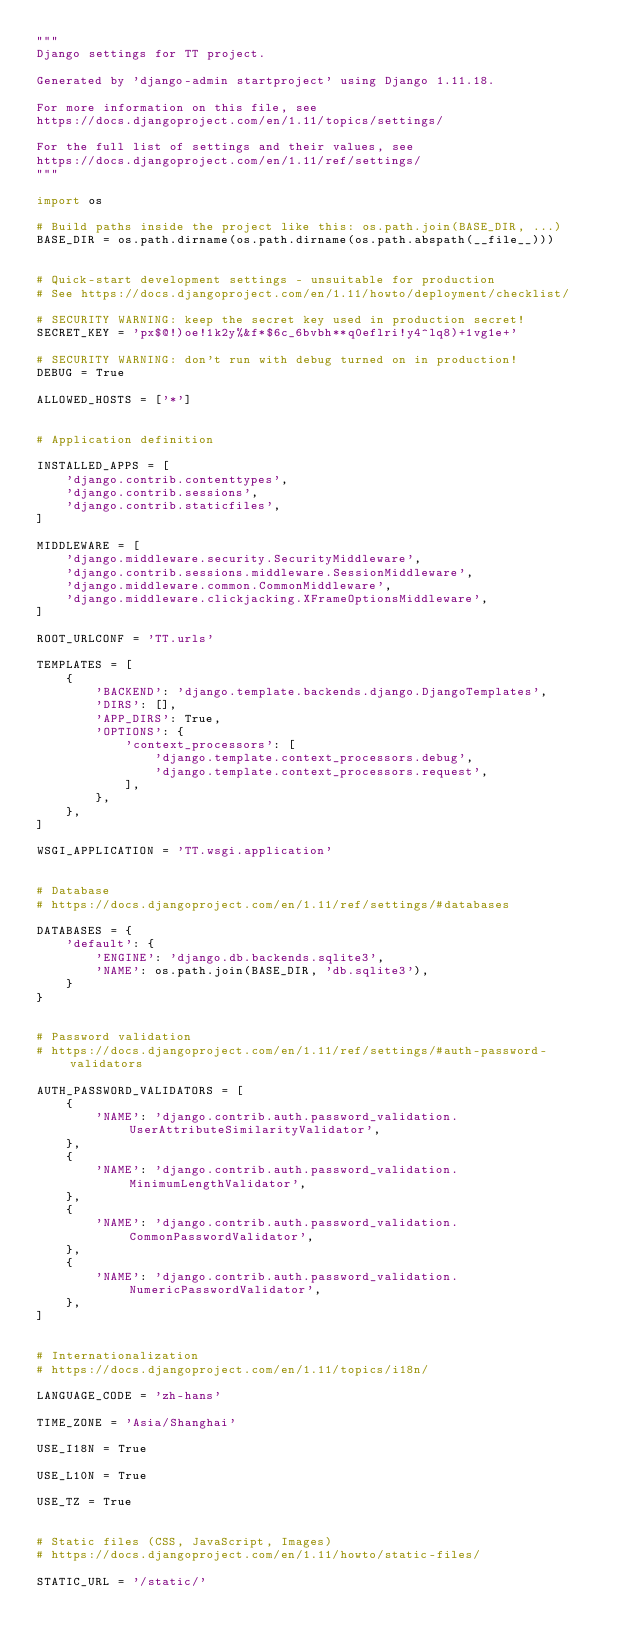<code> <loc_0><loc_0><loc_500><loc_500><_Python_>"""
Django settings for TT project.

Generated by 'django-admin startproject' using Django 1.11.18.

For more information on this file, see
https://docs.djangoproject.com/en/1.11/topics/settings/

For the full list of settings and their values, see
https://docs.djangoproject.com/en/1.11/ref/settings/
"""

import os

# Build paths inside the project like this: os.path.join(BASE_DIR, ...)
BASE_DIR = os.path.dirname(os.path.dirname(os.path.abspath(__file__)))


# Quick-start development settings - unsuitable for production
# See https://docs.djangoproject.com/en/1.11/howto/deployment/checklist/

# SECURITY WARNING: keep the secret key used in production secret!
SECRET_KEY = 'px$@!)oe!1k2y%&f*$6c_6bvbh**q0eflri!y4^lq8)+1vg1e+'

# SECURITY WARNING: don't run with debug turned on in production!
DEBUG = True

ALLOWED_HOSTS = ['*']


# Application definition

INSTALLED_APPS = [
    'django.contrib.contenttypes',
    'django.contrib.sessions',
    'django.contrib.staticfiles',
]

MIDDLEWARE = [
    'django.middleware.security.SecurityMiddleware',
    'django.contrib.sessions.middleware.SessionMiddleware',
    'django.middleware.common.CommonMiddleware',
    'django.middleware.clickjacking.XFrameOptionsMiddleware',
]

ROOT_URLCONF = 'TT.urls'

TEMPLATES = [
    {
        'BACKEND': 'django.template.backends.django.DjangoTemplates',
        'DIRS': [],
        'APP_DIRS': True,
        'OPTIONS': {
            'context_processors': [
                'django.template.context_processors.debug',
                'django.template.context_processors.request',
            ],
        },
    },
]

WSGI_APPLICATION = 'TT.wsgi.application'


# Database
# https://docs.djangoproject.com/en/1.11/ref/settings/#databases

DATABASES = {
    'default': {
        'ENGINE': 'django.db.backends.sqlite3',
        'NAME': os.path.join(BASE_DIR, 'db.sqlite3'),
    }
}


# Password validation
# https://docs.djangoproject.com/en/1.11/ref/settings/#auth-password-validators

AUTH_PASSWORD_VALIDATORS = [
    {
        'NAME': 'django.contrib.auth.password_validation.UserAttributeSimilarityValidator',
    },
    {
        'NAME': 'django.contrib.auth.password_validation.MinimumLengthValidator',
    },
    {
        'NAME': 'django.contrib.auth.password_validation.CommonPasswordValidator',
    },
    {
        'NAME': 'django.contrib.auth.password_validation.NumericPasswordValidator',
    },
]


# Internationalization
# https://docs.djangoproject.com/en/1.11/topics/i18n/

LANGUAGE_CODE = 'zh-hans'

TIME_ZONE = 'Asia/Shanghai'

USE_I18N = True

USE_L10N = True

USE_TZ = True


# Static files (CSS, JavaScript, Images)
# https://docs.djangoproject.com/en/1.11/howto/static-files/

STATIC_URL = '/static/'
</code> 